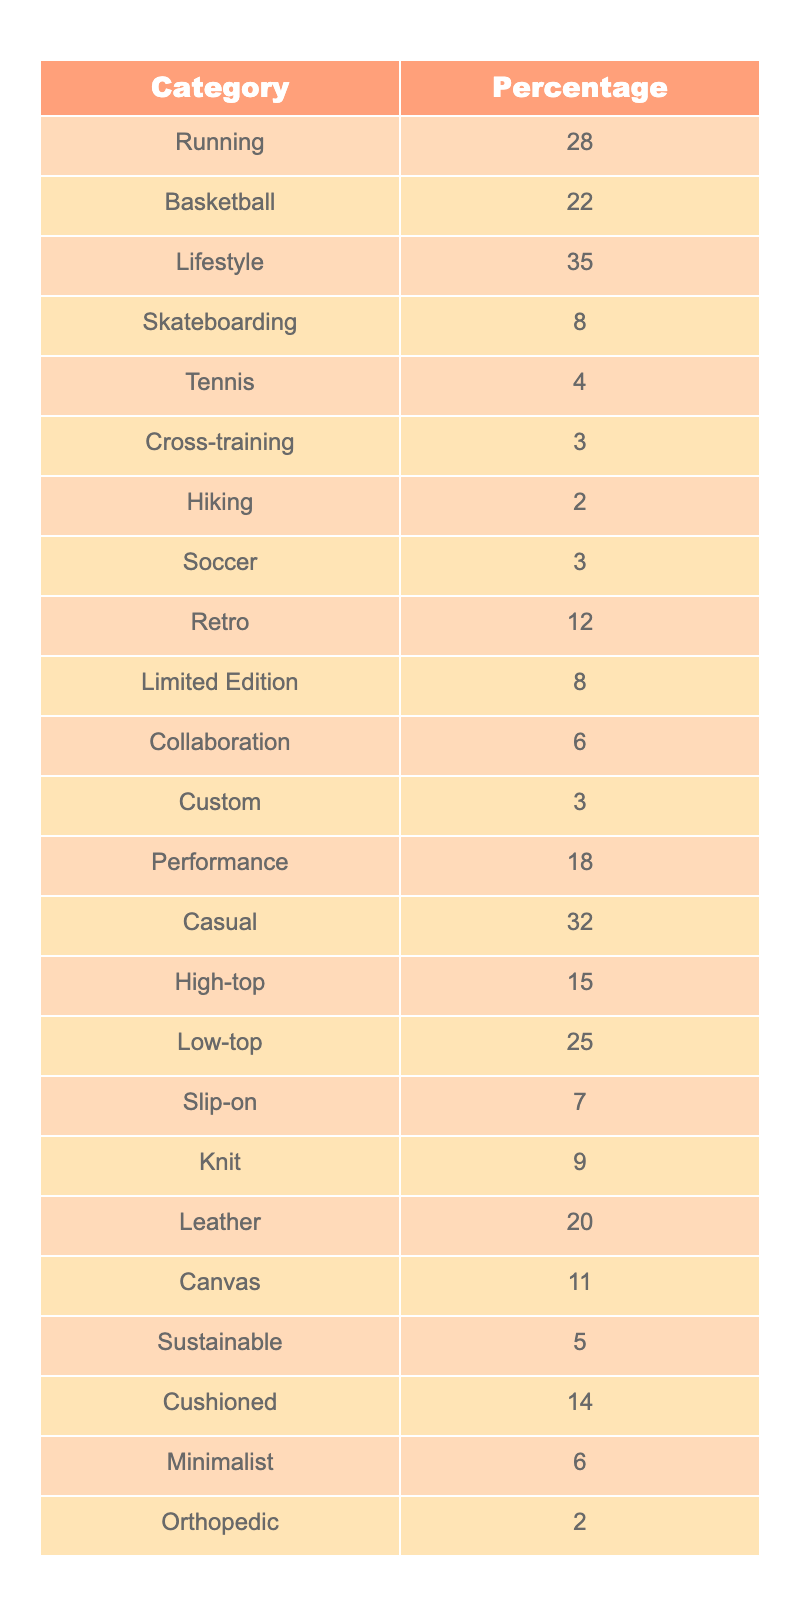What percentage of sneakers discussed are in the Lifestyle category? The table indicates that the Lifestyle category comprises 35% of the total sneaker types discussed.
Answer: 35% Which category has the highest percentage of sneaker types? The highest percentage is in the Lifestyle category at 35%, which is more than any other category listed.
Answer: Lifestyle What is the total percentage of Performance and Casual sneakers combined? Adding the percentages for Performance (18%) and Casual (32%) gives a total of 50% (18 + 32 = 50).
Answer: 50% Are there more Retro or Limited Edition sneakers discussed? The table shows that Retro sneakers account for 12% while Limited Edition sneakers account for 8%, indicating that there are more Retro sneakers.
Answer: Yes What percentage of sneakers discussed are either High-tops or Low-tops? The total for High-top (15%) and Low-top (25%) sneakers is calculated as 15 + 25 = 40%.
Answer: 40% Is the percentage of Skateboarding sneakers more than that of Soccer sneakers? Skateboarding sneakers represent 8% while Soccer sneakers account for 3%, so Skateboarding has a higher percentage.
Answer: Yes What is the average percentage of the categories Tennis, Hiking, and Orthopedic combined? The combined percentages for Tennis (4%), Hiking (2%), and Orthopedic (2%) is 8% (4 + 2 + 2). The average is then 8/3 = 2.67%.
Answer: 2.67% Which category has the lowest percentage, and what is its value? The category with the lowest percentage is Orthopedic at 2%.
Answer: Orthopedic, 2% What percentage of sneakers discussed fall under the Collaboration and Custom categories combined? Collaboration represents 6% and Custom represents 3%, so combining these gives 6 + 3 = 9%.
Answer: 9% If we look at the categories under 10%, how many are there and what are they? The categories under 10% are Tennis (4%), Hiking (2%), Cross-training (3%), Soccer (3%), Limited Edition (8%), and Custom (3%). There are 6 categories.
Answer: 6 categories: Tennis, Hiking, Cross-training, Soccer, Limited Edition, Custom 